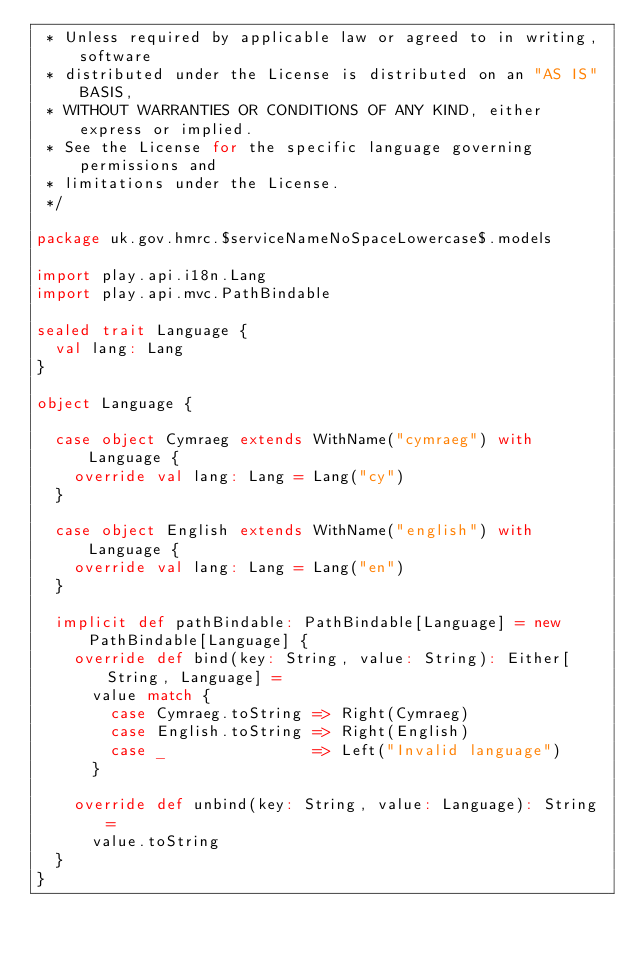<code> <loc_0><loc_0><loc_500><loc_500><_Scala_> * Unless required by applicable law or agreed to in writing, software
 * distributed under the License is distributed on an "AS IS" BASIS,
 * WITHOUT WARRANTIES OR CONDITIONS OF ANY KIND, either express or implied.
 * See the License for the specific language governing permissions and
 * limitations under the License.
 */

package uk.gov.hmrc.$serviceNameNoSpaceLowercase$.models

import play.api.i18n.Lang
import play.api.mvc.PathBindable

sealed trait Language {
  val lang: Lang
}

object Language {

  case object Cymraeg extends WithName("cymraeg") with Language {
    override val lang: Lang = Lang("cy")
  }

  case object English extends WithName("english") with Language {
    override val lang: Lang = Lang("en")
  }

  implicit def pathBindable: PathBindable[Language] = new PathBindable[Language] {
    override def bind(key: String, value: String): Either[String, Language] =
      value match {
        case Cymraeg.toString => Right(Cymraeg)
        case English.toString => Right(English)
        case _                => Left("Invalid language")
      }

    override def unbind(key: String, value: Language): String =
      value.toString
  }
}
</code> 